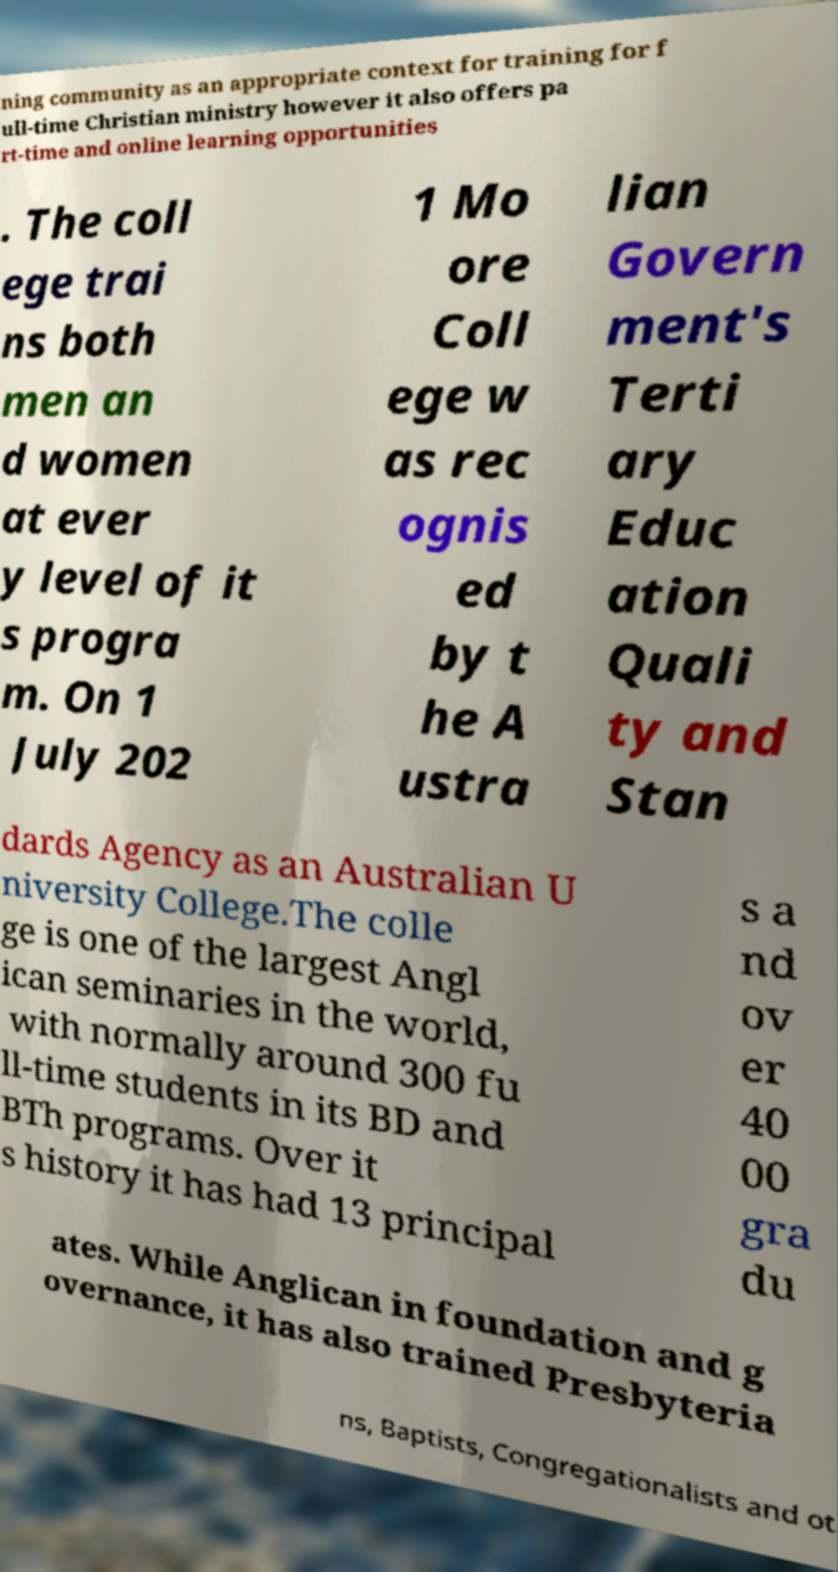Could you extract and type out the text from this image? ning community as an appropriate context for training for f ull-time Christian ministry however it also offers pa rt-time and online learning opportunities . The coll ege trai ns both men an d women at ever y level of it s progra m. On 1 July 202 1 Mo ore Coll ege w as rec ognis ed by t he A ustra lian Govern ment's Terti ary Educ ation Quali ty and Stan dards Agency as an Australian U niversity College.The colle ge is one of the largest Angl ican seminaries in the world, with normally around 300 fu ll-time students in its BD and BTh programs. Over it s history it has had 13 principal s a nd ov er 40 00 gra du ates. While Anglican in foundation and g overnance, it has also trained Presbyteria ns, Baptists, Congregationalists and ot 